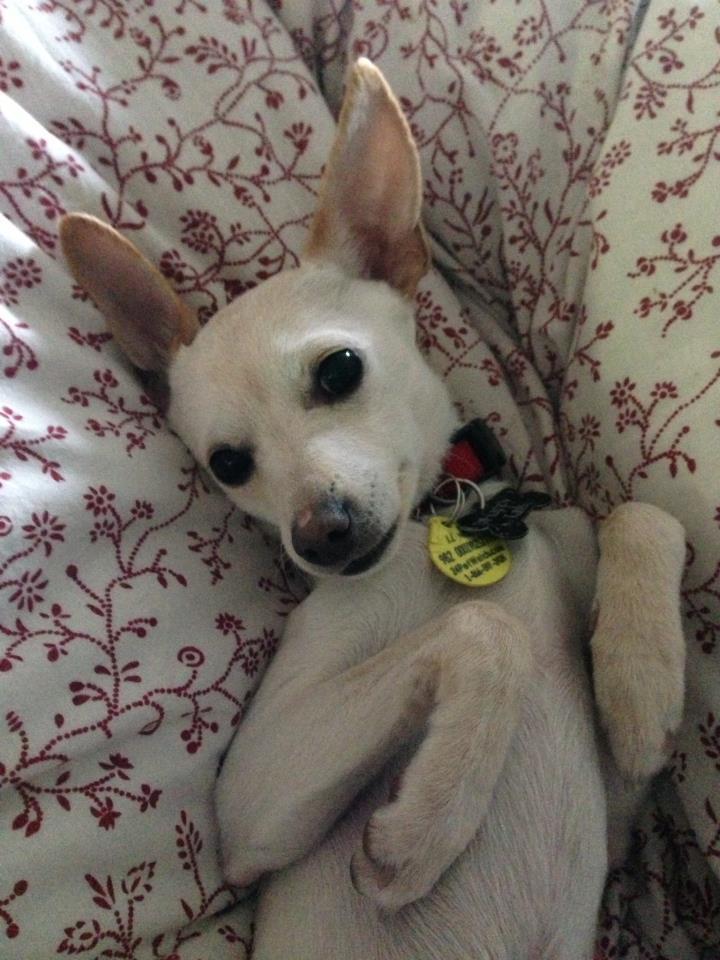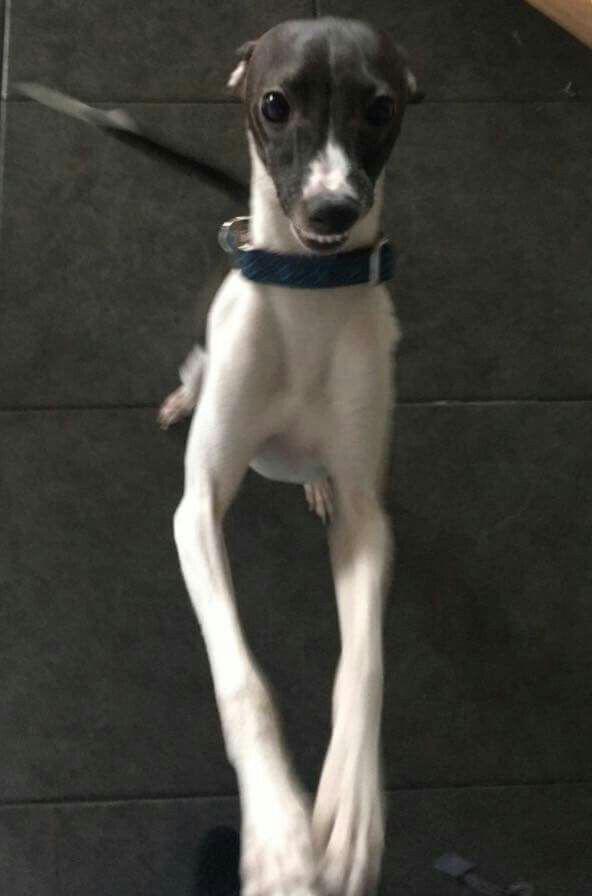The first image is the image on the left, the second image is the image on the right. Considering the images on both sides, is "An image shows just one hound, reclining with paws extended forward." valid? Answer yes or no. Yes. The first image is the image on the left, the second image is the image on the right. Given the left and right images, does the statement "There are two dogs in total" hold true? Answer yes or no. Yes. 